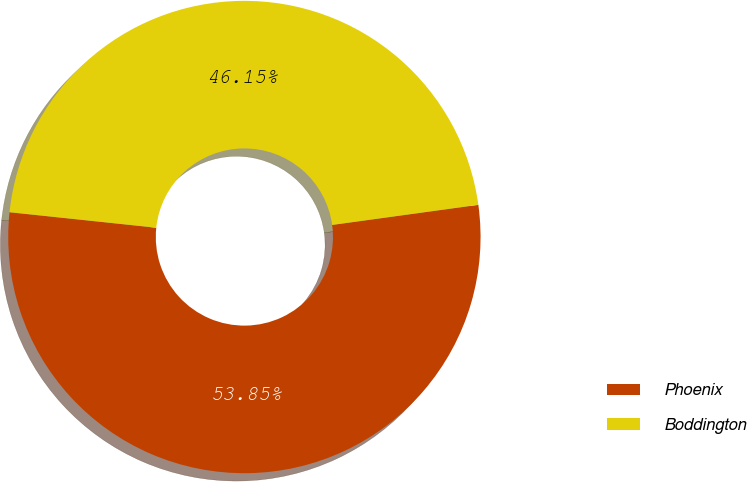Convert chart to OTSL. <chart><loc_0><loc_0><loc_500><loc_500><pie_chart><fcel>Phoenix<fcel>Boddington<nl><fcel>53.85%<fcel>46.15%<nl></chart> 